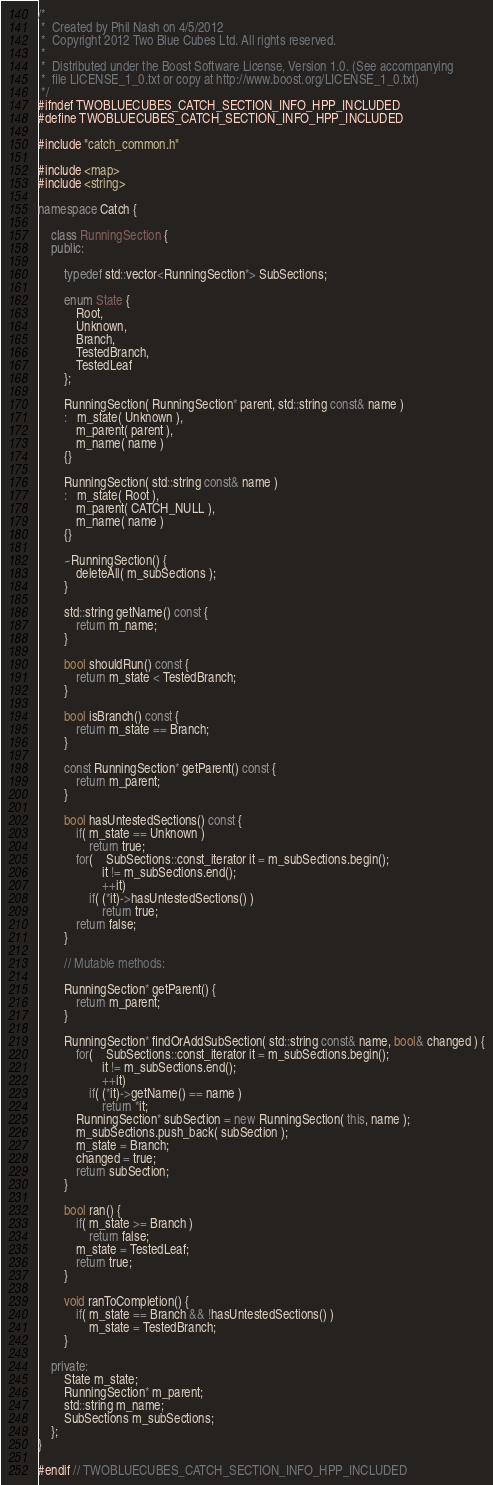Convert code to text. <code><loc_0><loc_0><loc_500><loc_500><_C++_>/*
 *  Created by Phil Nash on 4/5/2012
 *  Copyright 2012 Two Blue Cubes Ltd. All rights reserved.
 *
 *  Distributed under the Boost Software License, Version 1.0. (See accompanying
 *  file LICENSE_1_0.txt or copy at http://www.boost.org/LICENSE_1_0.txt)
 */
#ifndef TWOBLUECUBES_CATCH_SECTION_INFO_HPP_INCLUDED
#define TWOBLUECUBES_CATCH_SECTION_INFO_HPP_INCLUDED

#include "catch_common.h"

#include <map>
#include <string>

namespace Catch {

    class RunningSection {
    public:

        typedef std::vector<RunningSection*> SubSections;

        enum State {
            Root,
            Unknown,
            Branch,
            TestedBranch,
            TestedLeaf
        };

        RunningSection( RunningSection* parent, std::string const& name )
        :   m_state( Unknown ),
            m_parent( parent ),
            m_name( name )
        {}

        RunningSection( std::string const& name )
        :   m_state( Root ),
            m_parent( CATCH_NULL ),
            m_name( name )
        {}

        ~RunningSection() {
            deleteAll( m_subSections );
        }

        std::string getName() const {
            return m_name;
        }

        bool shouldRun() const {
            return m_state < TestedBranch;
        }

        bool isBranch() const {
            return m_state == Branch;
        }

        const RunningSection* getParent() const {
            return m_parent;
        }

        bool hasUntestedSections() const {
            if( m_state == Unknown )
                return true;
            for(    SubSections::const_iterator it = m_subSections.begin();
                    it != m_subSections.end();
                    ++it)
                if( (*it)->hasUntestedSections() )
                    return true;
            return false;
        }

        // Mutable methods:

        RunningSection* getParent() {
            return m_parent;
        }

        RunningSection* findOrAddSubSection( std::string const& name, bool& changed ) {
            for(    SubSections::const_iterator it = m_subSections.begin();
                    it != m_subSections.end();
                    ++it)
                if( (*it)->getName() == name )
                    return *it;
            RunningSection* subSection = new RunningSection( this, name );
            m_subSections.push_back( subSection );
            m_state = Branch;
            changed = true;
            return subSection;
        }

        bool ran() {
            if( m_state >= Branch )
                return false;
            m_state = TestedLeaf;
            return true;
        }

        void ranToCompletion() {
            if( m_state == Branch && !hasUntestedSections() )
                m_state = TestedBranch;
        }

    private:
        State m_state;
        RunningSection* m_parent;
        std::string m_name;
        SubSections m_subSections;
    };
}

#endif // TWOBLUECUBES_CATCH_SECTION_INFO_HPP_INCLUDED
</code> 